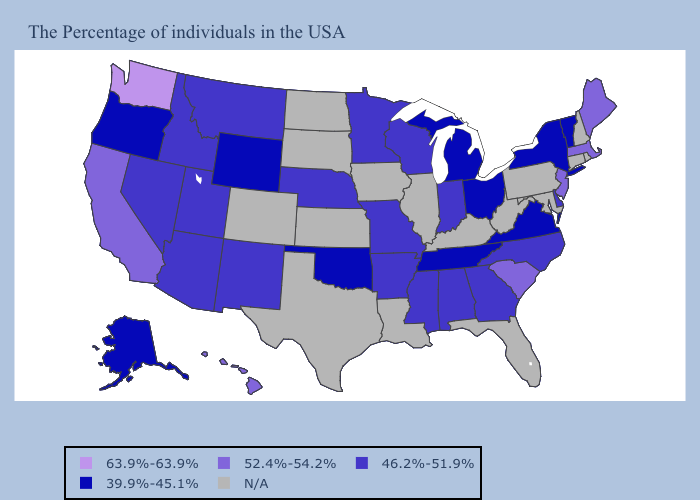Among the states that border Maryland , which have the highest value?
Be succinct. Delaware. Name the states that have a value in the range 39.9%-45.1%?
Quick response, please. Vermont, New York, Virginia, Ohio, Michigan, Tennessee, Oklahoma, Wyoming, Oregon, Alaska. Which states hav the highest value in the MidWest?
Keep it brief. Indiana, Wisconsin, Missouri, Minnesota, Nebraska. Does New York have the lowest value in the Northeast?
Be succinct. Yes. Name the states that have a value in the range 52.4%-54.2%?
Be succinct. Maine, Massachusetts, New Jersey, South Carolina, California, Hawaii. Which states have the lowest value in the Northeast?
Short answer required. Vermont, New York. Name the states that have a value in the range 52.4%-54.2%?
Short answer required. Maine, Massachusetts, New Jersey, South Carolina, California, Hawaii. Does the first symbol in the legend represent the smallest category?
Be succinct. No. Does Tennessee have the lowest value in the South?
Concise answer only. Yes. Which states have the lowest value in the West?
Quick response, please. Wyoming, Oregon, Alaska. What is the highest value in the USA?
Write a very short answer. 63.9%-63.9%. What is the value of Vermont?
Concise answer only. 39.9%-45.1%. Does Oklahoma have the lowest value in the South?
Quick response, please. Yes. 